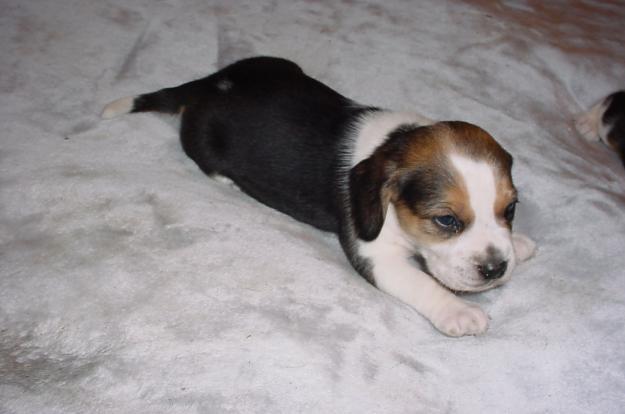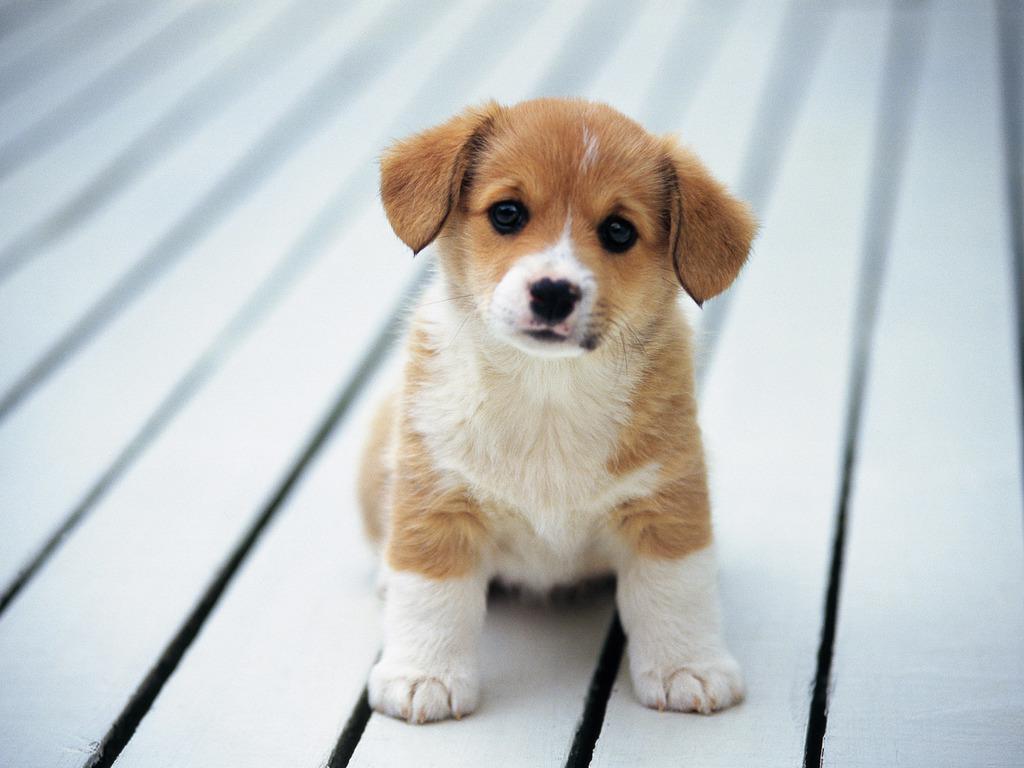The first image is the image on the left, the second image is the image on the right. For the images shown, is this caption "In one of the images there is a real dog whose tail is standing up straight." true? Answer yes or no. No. 